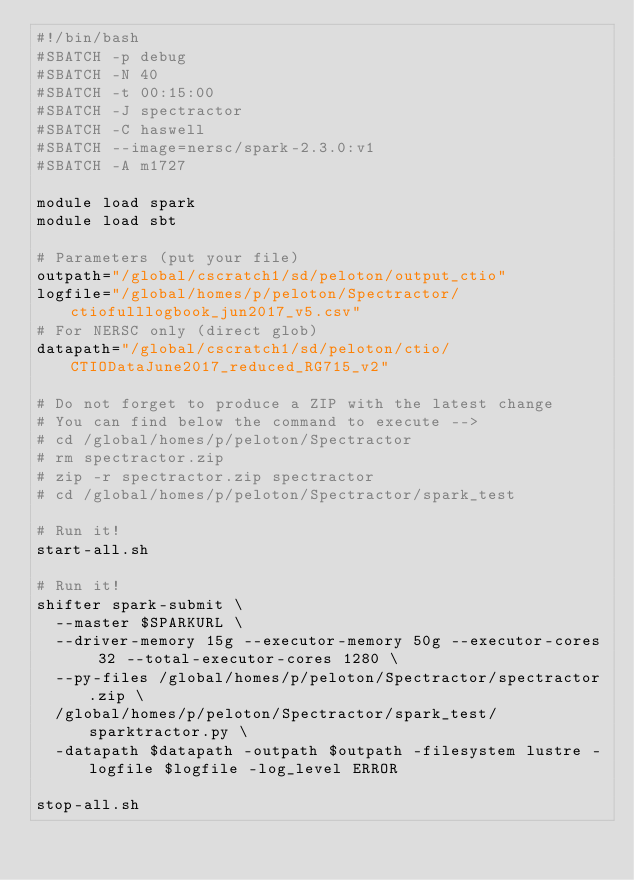Convert code to text. <code><loc_0><loc_0><loc_500><loc_500><_Bash_>#!/bin/bash
#SBATCH -p debug
#SBATCH -N 40
#SBATCH -t 00:15:00
#SBATCH -J spectractor
#SBATCH -C haswell
#SBATCH --image=nersc/spark-2.3.0:v1
#SBATCH -A m1727

module load spark
module load sbt

# Parameters (put your file)
outpath="/global/cscratch1/sd/peloton/output_ctio"
logfile="/global/homes/p/peloton/Spectractor/ctiofulllogbook_jun2017_v5.csv"
# For NERSC only (direct glob)
datapath="/global/cscratch1/sd/peloton/ctio/CTIODataJune2017_reduced_RG715_v2"

# Do not forget to produce a ZIP with the latest change
# You can find below the command to execute -->
# cd /global/homes/p/peloton/Spectractor
# rm spectractor.zip
# zip -r spectractor.zip spectractor
# cd /global/homes/p/peloton/Spectractor/spark_test

# Run it!
start-all.sh

# Run it!
shifter spark-submit \
  --master $SPARKURL \
  --driver-memory 15g --executor-memory 50g --executor-cores 32 --total-executor-cores 1280 \
  --py-files /global/homes/p/peloton/Spectractor/spectractor.zip \
  /global/homes/p/peloton/Spectractor/spark_test/sparktractor.py \
  -datapath $datapath -outpath $outpath -filesystem lustre -logfile $logfile -log_level ERROR

stop-all.sh
</code> 